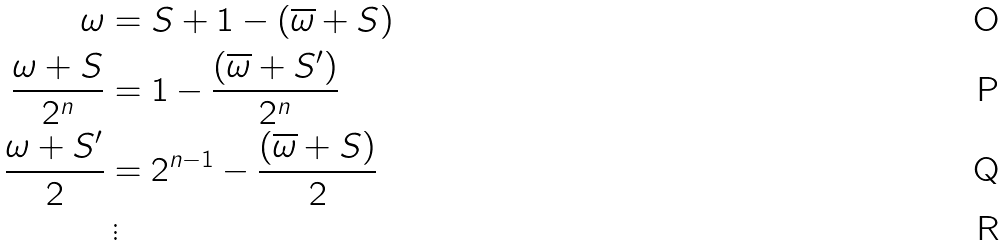<formula> <loc_0><loc_0><loc_500><loc_500>\omega & = S + 1 - ( \overline { \omega } + S ) \\ \frac { \omega + S } { 2 ^ { n } } & = 1 - \frac { ( \overline { \omega } + S ^ { \prime } ) } { 2 ^ { n } } \\ \frac { \omega + S ^ { \prime } } { 2 } & = 2 ^ { n - 1 } - \frac { ( \overline { \omega } + S ) } { 2 } \\ & \, \vdots</formula> 